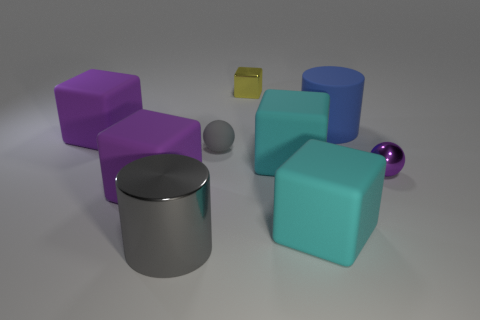Subtract all large purple cubes. How many cubes are left? 3 Add 1 cyan objects. How many objects exist? 10 Subtract 1 cylinders. How many cylinders are left? 1 Subtract all purple blocks. How many blocks are left? 3 Subtract all big metallic objects. Subtract all small yellow cubes. How many objects are left? 7 Add 4 small purple metallic balls. How many small purple metallic balls are left? 5 Add 2 gray shiny objects. How many gray shiny objects exist? 3 Subtract 1 cyan cubes. How many objects are left? 8 Subtract all cylinders. How many objects are left? 7 Subtract all yellow cylinders. Subtract all green cubes. How many cylinders are left? 2 